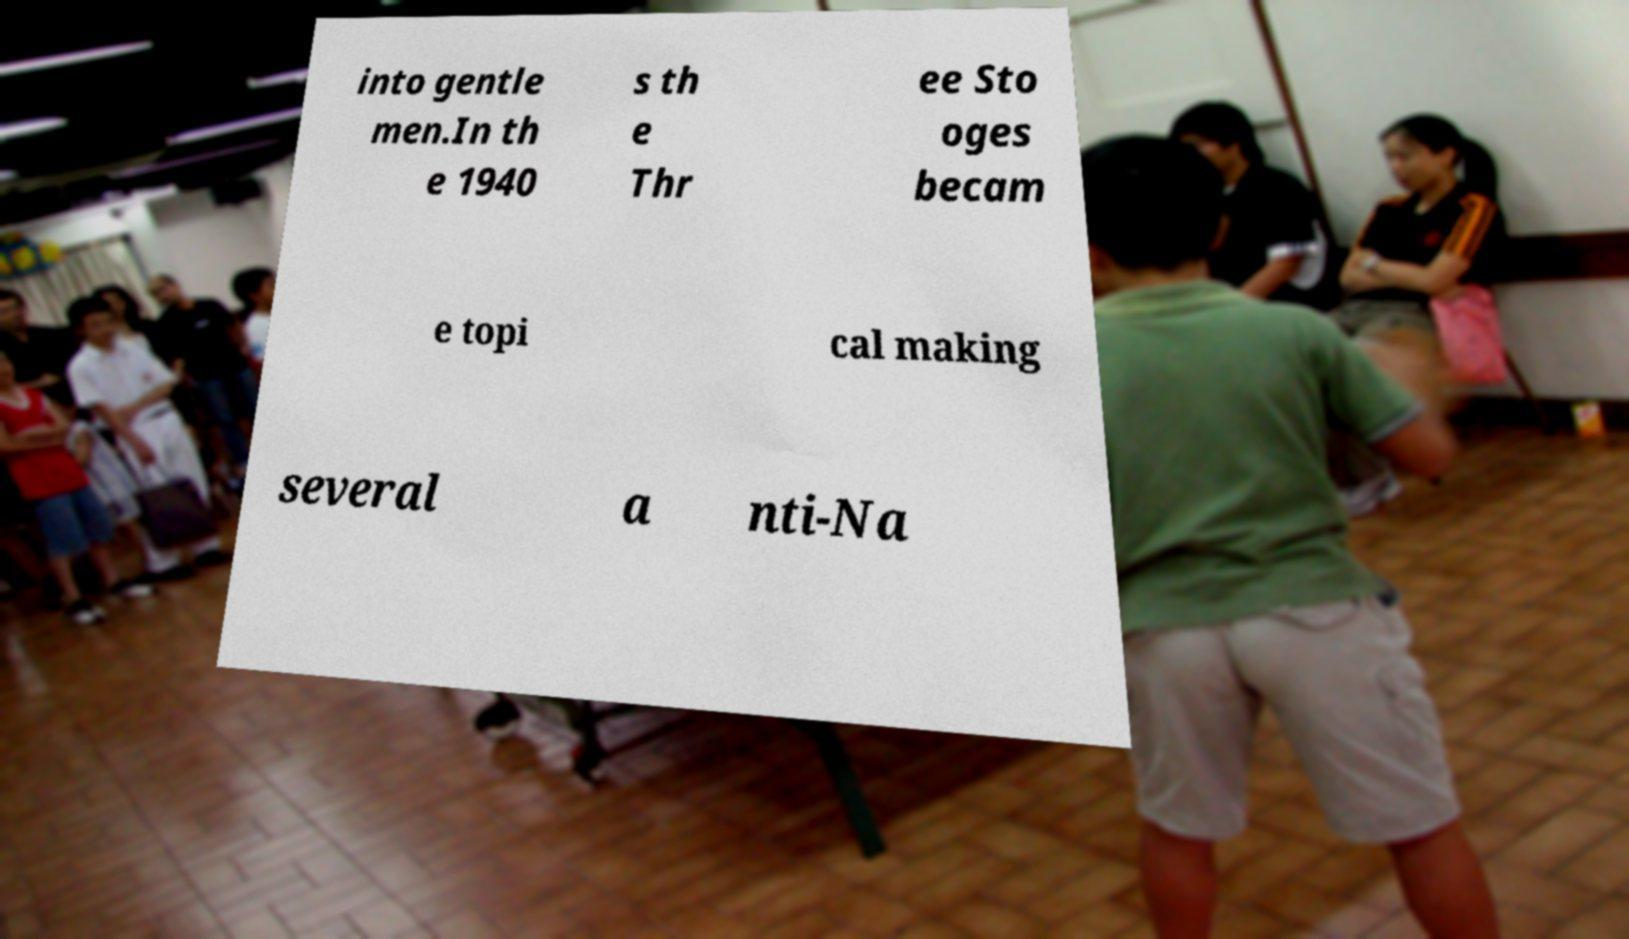For documentation purposes, I need the text within this image transcribed. Could you provide that? into gentle men.In th e 1940 s th e Thr ee Sto oges becam e topi cal making several a nti-Na 